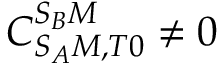<formula> <loc_0><loc_0><loc_500><loc_500>C _ { S _ { A } M , T 0 } ^ { S _ { B } M } \neq 0</formula> 